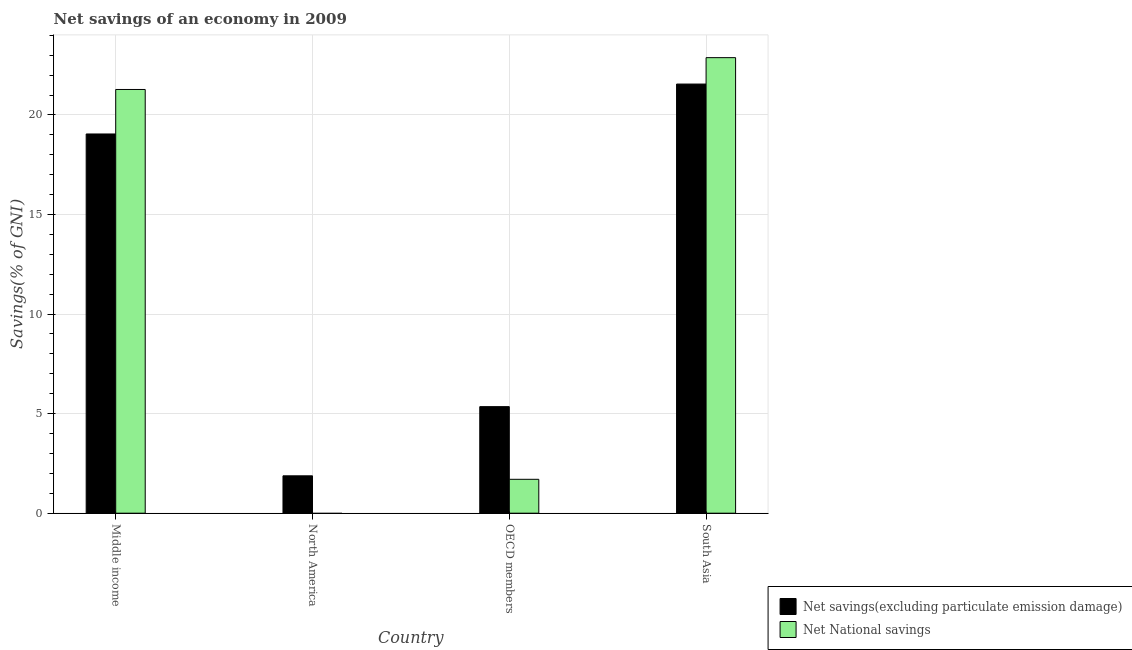How many bars are there on the 2nd tick from the right?
Offer a very short reply. 2. What is the label of the 1st group of bars from the left?
Your answer should be very brief. Middle income. What is the net national savings in Middle income?
Provide a succinct answer. 21.28. Across all countries, what is the maximum net savings(excluding particulate emission damage)?
Provide a succinct answer. 21.55. Across all countries, what is the minimum net savings(excluding particulate emission damage)?
Keep it short and to the point. 1.88. In which country was the net savings(excluding particulate emission damage) maximum?
Provide a succinct answer. South Asia. What is the total net savings(excluding particulate emission damage) in the graph?
Ensure brevity in your answer.  47.82. What is the difference between the net national savings in Middle income and that in South Asia?
Ensure brevity in your answer.  -1.6. What is the difference between the net savings(excluding particulate emission damage) in OECD members and the net national savings in North America?
Keep it short and to the point. 5.35. What is the average net savings(excluding particulate emission damage) per country?
Give a very brief answer. 11.96. What is the difference between the net national savings and net savings(excluding particulate emission damage) in Middle income?
Make the answer very short. 2.23. In how many countries, is the net savings(excluding particulate emission damage) greater than 5 %?
Offer a very short reply. 3. What is the ratio of the net savings(excluding particulate emission damage) in North America to that in OECD members?
Keep it short and to the point. 0.35. Is the net savings(excluding particulate emission damage) in North America less than that in OECD members?
Provide a succinct answer. Yes. What is the difference between the highest and the second highest net national savings?
Ensure brevity in your answer.  1.6. What is the difference between the highest and the lowest net national savings?
Ensure brevity in your answer.  22.88. In how many countries, is the net savings(excluding particulate emission damage) greater than the average net savings(excluding particulate emission damage) taken over all countries?
Offer a very short reply. 2. Is the sum of the net national savings in Middle income and South Asia greater than the maximum net savings(excluding particulate emission damage) across all countries?
Ensure brevity in your answer.  Yes. How many bars are there?
Provide a short and direct response. 7. How many countries are there in the graph?
Keep it short and to the point. 4. Does the graph contain any zero values?
Your answer should be compact. Yes. How many legend labels are there?
Keep it short and to the point. 2. How are the legend labels stacked?
Your answer should be very brief. Vertical. What is the title of the graph?
Your answer should be very brief. Net savings of an economy in 2009. What is the label or title of the Y-axis?
Keep it short and to the point. Savings(% of GNI). What is the Savings(% of GNI) in Net savings(excluding particulate emission damage) in Middle income?
Keep it short and to the point. 19.04. What is the Savings(% of GNI) of Net National savings in Middle income?
Offer a terse response. 21.28. What is the Savings(% of GNI) of Net savings(excluding particulate emission damage) in North America?
Give a very brief answer. 1.88. What is the Savings(% of GNI) in Net National savings in North America?
Make the answer very short. 0. What is the Savings(% of GNI) in Net savings(excluding particulate emission damage) in OECD members?
Offer a very short reply. 5.35. What is the Savings(% of GNI) in Net National savings in OECD members?
Provide a succinct answer. 1.7. What is the Savings(% of GNI) in Net savings(excluding particulate emission damage) in South Asia?
Your answer should be compact. 21.55. What is the Savings(% of GNI) of Net National savings in South Asia?
Your answer should be very brief. 22.88. Across all countries, what is the maximum Savings(% of GNI) in Net savings(excluding particulate emission damage)?
Your answer should be compact. 21.55. Across all countries, what is the maximum Savings(% of GNI) of Net National savings?
Keep it short and to the point. 22.88. Across all countries, what is the minimum Savings(% of GNI) in Net savings(excluding particulate emission damage)?
Provide a succinct answer. 1.88. What is the total Savings(% of GNI) of Net savings(excluding particulate emission damage) in the graph?
Ensure brevity in your answer.  47.82. What is the total Savings(% of GNI) in Net National savings in the graph?
Your answer should be compact. 45.86. What is the difference between the Savings(% of GNI) in Net savings(excluding particulate emission damage) in Middle income and that in North America?
Provide a short and direct response. 17.17. What is the difference between the Savings(% of GNI) of Net savings(excluding particulate emission damage) in Middle income and that in OECD members?
Your answer should be compact. 13.69. What is the difference between the Savings(% of GNI) of Net National savings in Middle income and that in OECD members?
Offer a very short reply. 19.58. What is the difference between the Savings(% of GNI) in Net savings(excluding particulate emission damage) in Middle income and that in South Asia?
Offer a terse response. -2.51. What is the difference between the Savings(% of GNI) of Net National savings in Middle income and that in South Asia?
Ensure brevity in your answer.  -1.6. What is the difference between the Savings(% of GNI) of Net savings(excluding particulate emission damage) in North America and that in OECD members?
Ensure brevity in your answer.  -3.47. What is the difference between the Savings(% of GNI) in Net savings(excluding particulate emission damage) in North America and that in South Asia?
Your response must be concise. -19.67. What is the difference between the Savings(% of GNI) in Net savings(excluding particulate emission damage) in OECD members and that in South Asia?
Provide a short and direct response. -16.2. What is the difference between the Savings(% of GNI) of Net National savings in OECD members and that in South Asia?
Give a very brief answer. -21.18. What is the difference between the Savings(% of GNI) of Net savings(excluding particulate emission damage) in Middle income and the Savings(% of GNI) of Net National savings in OECD members?
Your response must be concise. 17.34. What is the difference between the Savings(% of GNI) in Net savings(excluding particulate emission damage) in Middle income and the Savings(% of GNI) in Net National savings in South Asia?
Your answer should be very brief. -3.83. What is the difference between the Savings(% of GNI) in Net savings(excluding particulate emission damage) in North America and the Savings(% of GNI) in Net National savings in OECD members?
Your response must be concise. 0.18. What is the difference between the Savings(% of GNI) of Net savings(excluding particulate emission damage) in North America and the Savings(% of GNI) of Net National savings in South Asia?
Keep it short and to the point. -21. What is the difference between the Savings(% of GNI) in Net savings(excluding particulate emission damage) in OECD members and the Savings(% of GNI) in Net National savings in South Asia?
Your answer should be compact. -17.53. What is the average Savings(% of GNI) in Net savings(excluding particulate emission damage) per country?
Provide a short and direct response. 11.96. What is the average Savings(% of GNI) of Net National savings per country?
Make the answer very short. 11.46. What is the difference between the Savings(% of GNI) of Net savings(excluding particulate emission damage) and Savings(% of GNI) of Net National savings in Middle income?
Keep it short and to the point. -2.23. What is the difference between the Savings(% of GNI) of Net savings(excluding particulate emission damage) and Savings(% of GNI) of Net National savings in OECD members?
Keep it short and to the point. 3.65. What is the difference between the Savings(% of GNI) in Net savings(excluding particulate emission damage) and Savings(% of GNI) in Net National savings in South Asia?
Keep it short and to the point. -1.33. What is the ratio of the Savings(% of GNI) in Net savings(excluding particulate emission damage) in Middle income to that in North America?
Provide a short and direct response. 10.15. What is the ratio of the Savings(% of GNI) in Net savings(excluding particulate emission damage) in Middle income to that in OECD members?
Ensure brevity in your answer.  3.56. What is the ratio of the Savings(% of GNI) of Net National savings in Middle income to that in OECD members?
Offer a terse response. 12.5. What is the ratio of the Savings(% of GNI) of Net savings(excluding particulate emission damage) in Middle income to that in South Asia?
Offer a very short reply. 0.88. What is the ratio of the Savings(% of GNI) of Net National savings in Middle income to that in South Asia?
Keep it short and to the point. 0.93. What is the ratio of the Savings(% of GNI) in Net savings(excluding particulate emission damage) in North America to that in OECD members?
Keep it short and to the point. 0.35. What is the ratio of the Savings(% of GNI) in Net savings(excluding particulate emission damage) in North America to that in South Asia?
Your answer should be compact. 0.09. What is the ratio of the Savings(% of GNI) in Net savings(excluding particulate emission damage) in OECD members to that in South Asia?
Provide a succinct answer. 0.25. What is the ratio of the Savings(% of GNI) in Net National savings in OECD members to that in South Asia?
Your answer should be very brief. 0.07. What is the difference between the highest and the second highest Savings(% of GNI) in Net savings(excluding particulate emission damage)?
Your answer should be compact. 2.51. What is the difference between the highest and the second highest Savings(% of GNI) of Net National savings?
Offer a terse response. 1.6. What is the difference between the highest and the lowest Savings(% of GNI) of Net savings(excluding particulate emission damage)?
Make the answer very short. 19.67. What is the difference between the highest and the lowest Savings(% of GNI) in Net National savings?
Make the answer very short. 22.88. 